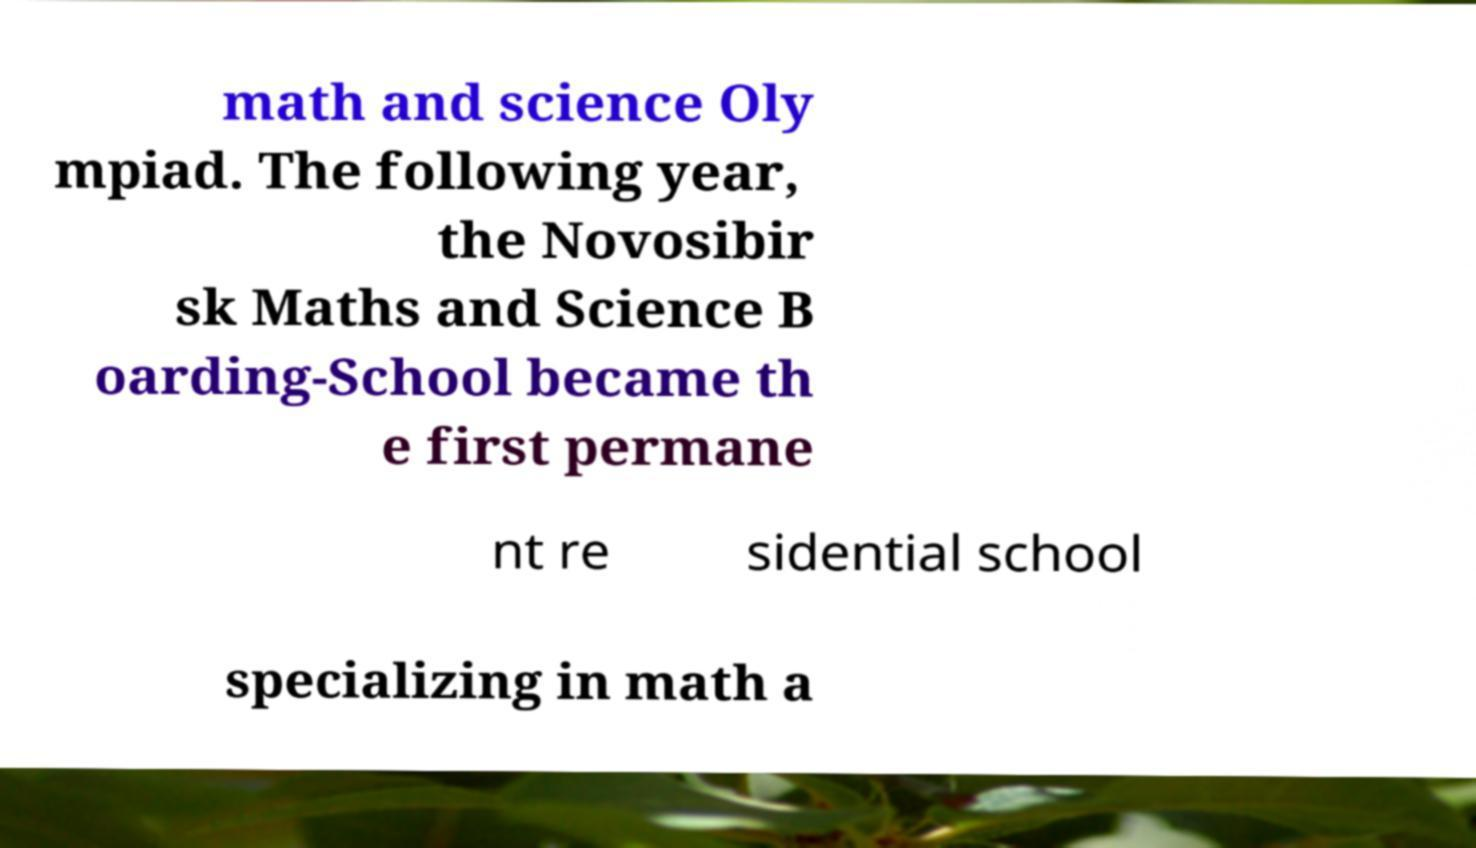Please read and relay the text visible in this image. What does it say? math and science Oly mpiad. The following year, the Novosibir sk Maths and Science B oarding-School became th e first permane nt re sidential school specializing in math a 